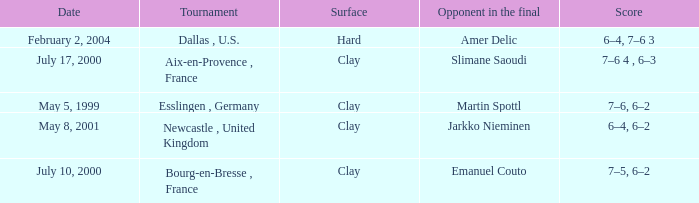What is the Date of the game with a Score of 6–4, 6–2? May 8, 2001. 